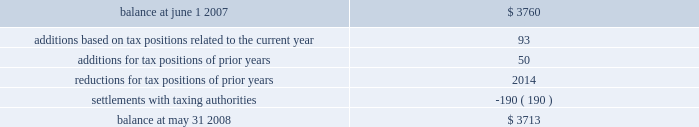Notes to consolidated financial statements 2014 ( continued ) company 2019s financial statements and establishes guidelines for recognition and measurement of a tax position taken or expected to be taken in a tax return .
As a result of this adoption , we recorded a $ 1.5 million increase in the liability for unrecognized income tax benefits , which was accounted for as a $ 1.0 million reduction to the june 1 , 2007 balance of retained earnings and a $ 0.5 million reduction to the june 1 , 2007 balance of additional paid-in capital .
As of the adoption date , other long-term liabilities included liabilities for unrecognized income tax benefits of $ 3.8 million and accrued interest and penalties of $ 0.7 million .
A reconciliation of the beginning and ending amount of unrecognized tax benefits is as follows ( in thousands ) : .
As of may 31 , 2008 , the total amount of gross unrecognized tax benefits that , if recognized , would affect the effective tax rate is $ 3.7 million .
We recognize accrued interest related to unrecognized income tax benefits in interest expense and accrued penalty expense related to unrecognized tax benefits in sales , general and administrative expenses .
During fiscal 2008 , we recorded $ 0.3 million of accrued interest and penalty expense related to the unrecognized income tax benefits .
We anticipate the total amount of unrecognized income tax benefits will decrease by $ 1.1 million net of interest and penalties from our foreign operations within the next 12 months as a result of the expiration of the statute of limitations .
We conduct business globally and file income tax returns in the united states federal jurisdiction and various state and foreign jurisdictions .
In the normal course of business , we are subject to examination by taxing authorities throughout the world , including such major jurisdictions as the united states and canada .
With few exceptions , we are no longer subject to income tax examinations for years ended may 31 , 2003 and prior .
We are currently under audit by the internal revenue service of the united states for the 2004 to 2005 tax years .
We expect that the examination phase of the audit for the years 2004 to 2005 will conclude in fiscal 2009 .
Note 8 2014shareholders 2019 equity on april 5 , 2007 , our board of directors approved a share repurchase program that authorized the purchase of up to $ 100 million of global payments 2019 stock in the open market or as otherwise may be determined by us , subject to market conditions , business opportunities , and other factors .
Under this authorization , we repurchased 2.3 million shares of our common stock during fiscal 2008 at a cost of $ 87.0 million , or an average of $ 37.85 per share , including commissions .
As of may 31 , 2008 , we had $ 13.0 million remaining under our current share repurchase authorization .
No amounts were repurchased during fiscal 2007 .
Note 9 2014share-based awards and options as of may 31 , 2008 , we had four share-based employee compensation plans .
For all share-based awards granted after june 1 , 2006 , compensation expense is recognized on a straight-line basis .
The fair value of share- based awards granted prior to june 1 , 2006 is amortized as compensation expense on an accelerated basis from the date of the grant .
There was no share-based compensation capitalized during fiscal 2008 , 2007 , and 2006. .
What is the net change in the balance of unrecognized tax benefits from 2007 to 2008? 
Computations: (3713 - 3760)
Answer: -47.0. Notes to consolidated financial statements 2014 ( continued ) company 2019s financial statements and establishes guidelines for recognition and measurement of a tax position taken or expected to be taken in a tax return .
As a result of this adoption , we recorded a $ 1.5 million increase in the liability for unrecognized income tax benefits , which was accounted for as a $ 1.0 million reduction to the june 1 , 2007 balance of retained earnings and a $ 0.5 million reduction to the june 1 , 2007 balance of additional paid-in capital .
As of the adoption date , other long-term liabilities included liabilities for unrecognized income tax benefits of $ 3.8 million and accrued interest and penalties of $ 0.7 million .
A reconciliation of the beginning and ending amount of unrecognized tax benefits is as follows ( in thousands ) : .
As of may 31 , 2008 , the total amount of gross unrecognized tax benefits that , if recognized , would affect the effective tax rate is $ 3.7 million .
We recognize accrued interest related to unrecognized income tax benefits in interest expense and accrued penalty expense related to unrecognized tax benefits in sales , general and administrative expenses .
During fiscal 2008 , we recorded $ 0.3 million of accrued interest and penalty expense related to the unrecognized income tax benefits .
We anticipate the total amount of unrecognized income tax benefits will decrease by $ 1.1 million net of interest and penalties from our foreign operations within the next 12 months as a result of the expiration of the statute of limitations .
We conduct business globally and file income tax returns in the united states federal jurisdiction and various state and foreign jurisdictions .
In the normal course of business , we are subject to examination by taxing authorities throughout the world , including such major jurisdictions as the united states and canada .
With few exceptions , we are no longer subject to income tax examinations for years ended may 31 , 2003 and prior .
We are currently under audit by the internal revenue service of the united states for the 2004 to 2005 tax years .
We expect that the examination phase of the audit for the years 2004 to 2005 will conclude in fiscal 2009 .
Note 8 2014shareholders 2019 equity on april 5 , 2007 , our board of directors approved a share repurchase program that authorized the purchase of up to $ 100 million of global payments 2019 stock in the open market or as otherwise may be determined by us , subject to market conditions , business opportunities , and other factors .
Under this authorization , we repurchased 2.3 million shares of our common stock during fiscal 2008 at a cost of $ 87.0 million , or an average of $ 37.85 per share , including commissions .
As of may 31 , 2008 , we had $ 13.0 million remaining under our current share repurchase authorization .
No amounts were repurchased during fiscal 2007 .
Note 9 2014share-based awards and options as of may 31 , 2008 , we had four share-based employee compensation plans .
For all share-based awards granted after june 1 , 2006 , compensation expense is recognized on a straight-line basis .
The fair value of share- based awards granted prior to june 1 , 2006 is amortized as compensation expense on an accelerated basis from the date of the grant .
There was no share-based compensation capitalized during fiscal 2008 , 2007 , and 2006. .
What is the number of remaining shares under the repurchase authorization , assuming an average share price of $ 37.85? 
Computations: ((13.0 * 1000000) / 37.85)
Answer: 343461.03038. 